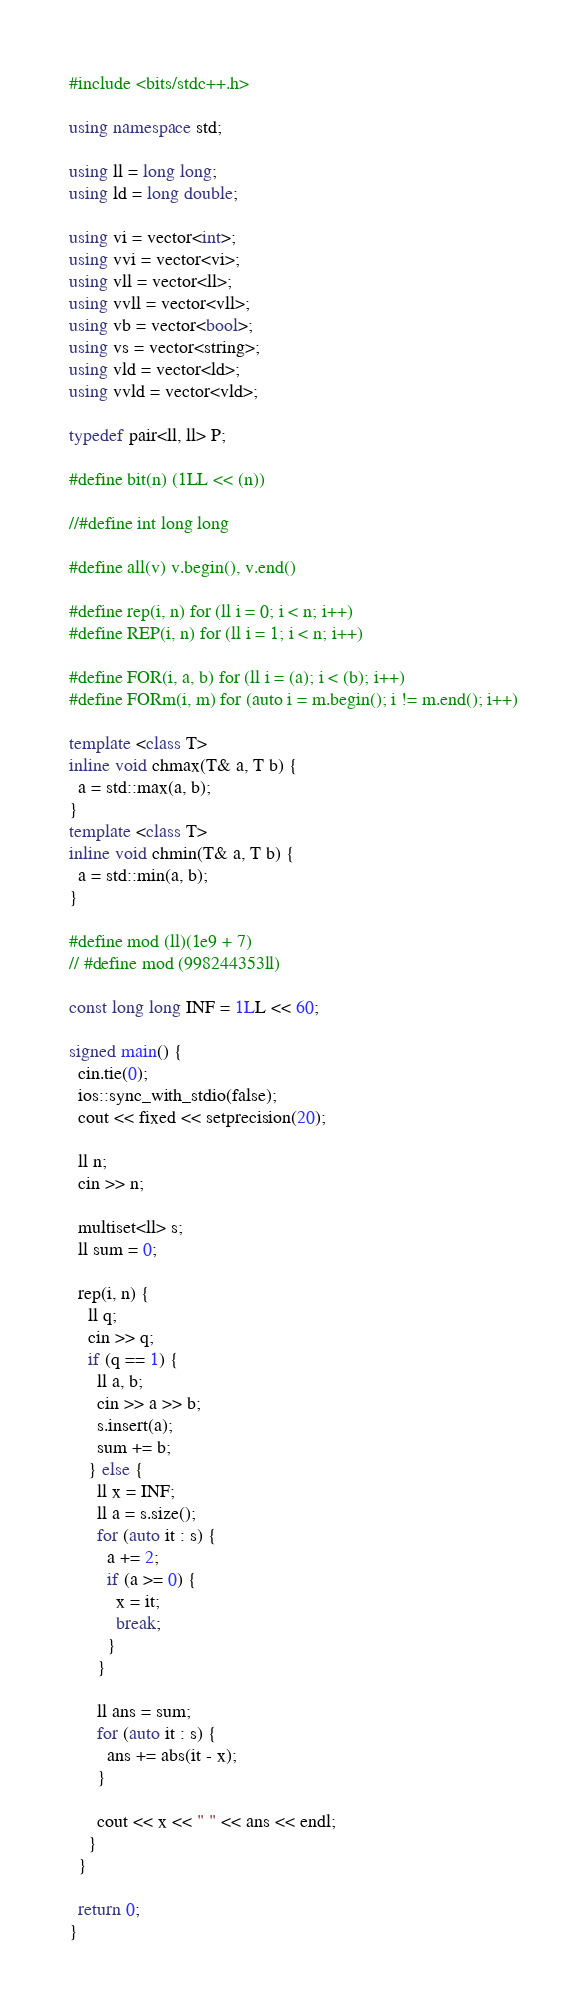Convert code to text. <code><loc_0><loc_0><loc_500><loc_500><_C++_>#include <bits/stdc++.h>

using namespace std;

using ll = long long;
using ld = long double;

using vi = vector<int>;
using vvi = vector<vi>;
using vll = vector<ll>;
using vvll = vector<vll>;
using vb = vector<bool>;
using vs = vector<string>;
using vld = vector<ld>;
using vvld = vector<vld>;

typedef pair<ll, ll> P;

#define bit(n) (1LL << (n))

//#define int long long

#define all(v) v.begin(), v.end()

#define rep(i, n) for (ll i = 0; i < n; i++)
#define REP(i, n) for (ll i = 1; i < n; i++)

#define FOR(i, a, b) for (ll i = (a); i < (b); i++)
#define FORm(i, m) for (auto i = m.begin(); i != m.end(); i++)

template <class T>
inline void chmax(T& a, T b) {
  a = std::max(a, b);
}
template <class T>
inline void chmin(T& a, T b) {
  a = std::min(a, b);
}

#define mod (ll)(1e9 + 7)
// #define mod (998244353ll)

const long long INF = 1LL << 60;

signed main() {
  cin.tie(0);
  ios::sync_with_stdio(false);
  cout << fixed << setprecision(20);

  ll n;
  cin >> n;

  multiset<ll> s;
  ll sum = 0;

  rep(i, n) {
    ll q;
    cin >> q;
    if (q == 1) {
      ll a, b;
      cin >> a >> b;
      s.insert(a);
      sum += b;
    } else {
      ll x = INF;
      ll a = s.size();
      for (auto it : s) {
        a += 2;
        if (a >= 0) {
          x = it;
          break;
        }
      }

      ll ans = sum;
      for (auto it : s) {
        ans += abs(it - x);
      }

      cout << x << " " << ans << endl;
    }
  }

  return 0;
}
</code> 